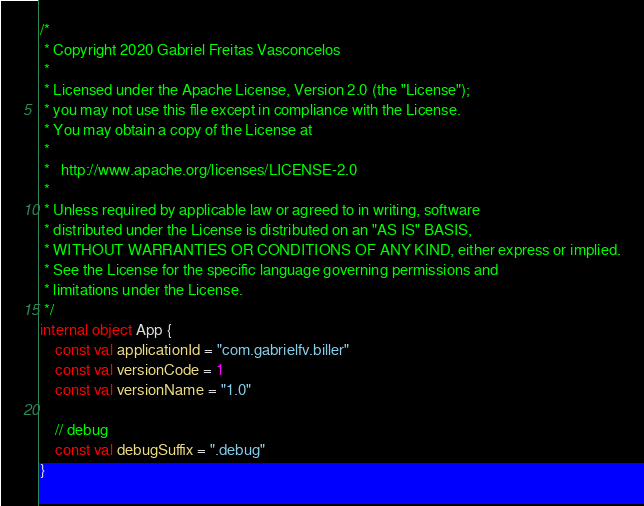<code> <loc_0><loc_0><loc_500><loc_500><_Kotlin_>/*
 * Copyright 2020 Gabriel Freitas Vasconcelos
 *
 * Licensed under the Apache License, Version 2.0 (the "License");
 * you may not use this file except in compliance with the License.
 * You may obtain a copy of the License at
 *
 *   http://www.apache.org/licenses/LICENSE-2.0
 *
 * Unless required by applicable law or agreed to in writing, software
 * distributed under the License is distributed on an "AS IS" BASIS,
 * WITHOUT WARRANTIES OR CONDITIONS OF ANY KIND, either express or implied.
 * See the License for the specific language governing permissions and
 * limitations under the License.
 */
internal object App {
    const val applicationId = "com.gabrielfv.biller"
    const val versionCode = 1
    const val versionName = "1.0"

    // debug
    const val debugSuffix = ".debug"
}</code> 